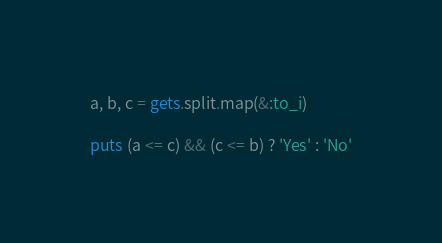Convert code to text. <code><loc_0><loc_0><loc_500><loc_500><_Ruby_>a, b, c = gets.split.map(&:to_i)

puts (a <= c) && (c <= b) ? 'Yes' : 'No'</code> 